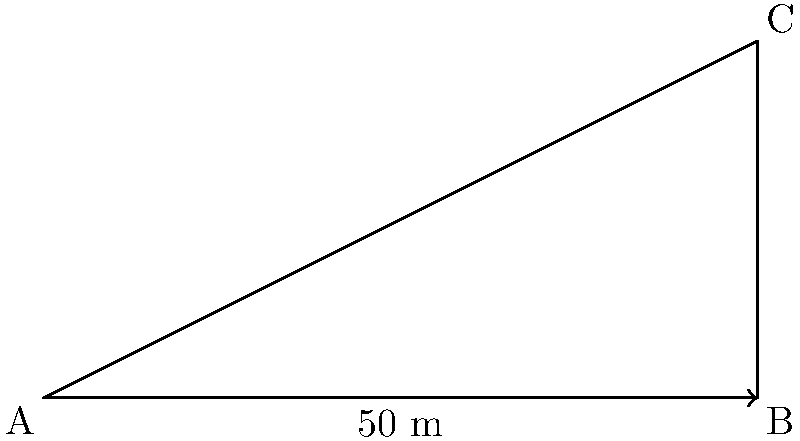As part of a forensic investigation, you need to determine the height of a building where a crime occurred. Standing 50 meters away from the base of the building, you measure the angle of elevation to the top of the building to be 60°. What is the height of the building to the nearest meter? Let's approach this step-by-step:

1) We can model this situation as a right-angled triangle, where:
   - The base of the triangle is the distance from where we're standing to the building (50 m)
   - The height of the triangle is the height of the building (what we're trying to find)
   - The angle between the base and the hypotenuse is 60°

2) In this right-angled triangle, we know:
   - The adjacent side (base) = 50 m
   - The angle = 60°
   - We need to find the opposite side (height)

3) This is a perfect scenario to use the tangent trigonometric function:

   $\tan(\theta) = \frac{\text{opposite}}{\text{adjacent}}$

4) Plugging in our known values:

   $\tan(60°) = \frac{\text{height}}{50}$

5) We can rearrange this to solve for height:

   $\text{height} = 50 \times \tan(60°)$

6) Now, let's calculate:
   - $\tan(60°) \approx 1.7321$
   - $50 \times 1.7321 = 86.6025$

7) Rounding to the nearest meter:

   $\text{height} \approx 87$ meters
Answer: 87 meters 